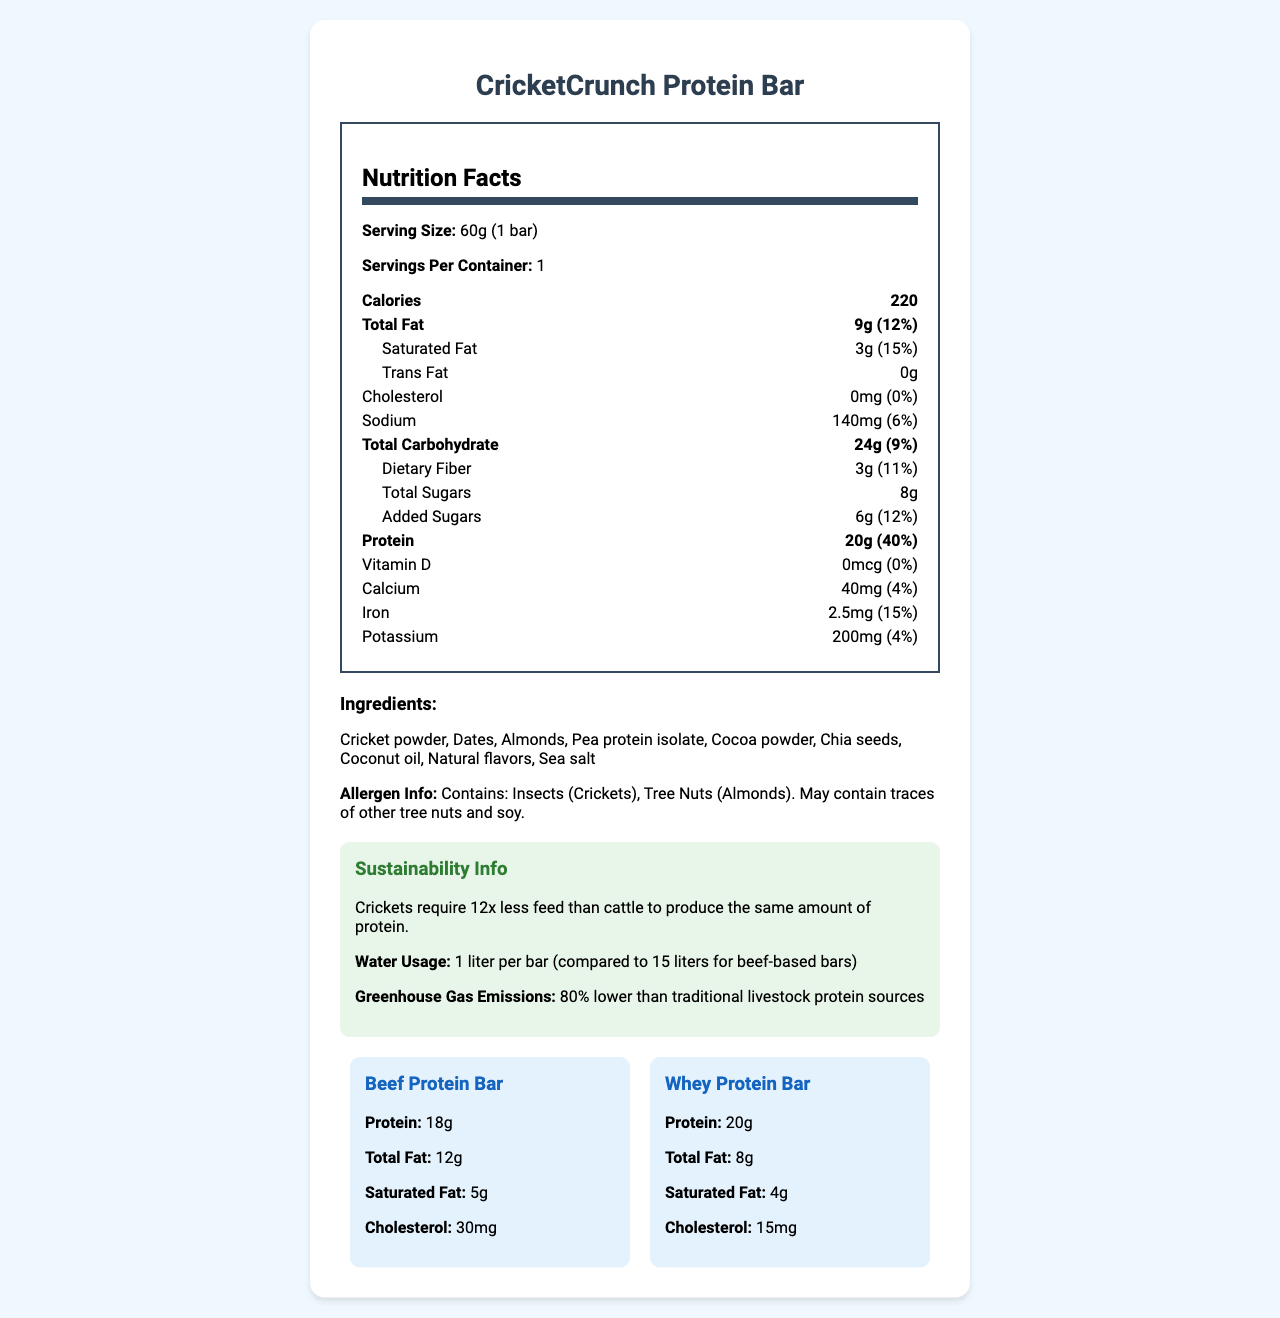what is the serving size of the CricketCrunch Protein Bar? The serving size is clearly listed as "60g (1 bar)" in the document.
Answer: 60g (1 bar) how many calories are there per serving? The document lists the calories per serving as 220.
Answer: 220 how much protein is in the CricketCrunch Protein Bar compared to a traditional beef protein bar? The CricketCrunch Protein Bar contains 20g of protein, while the beef protein bar contains 18g, as stated in the comparison section.
Answer: CricketCrunch Protein Bar: 20g; Beef Protein Bar: 18g what is the percent daily value of iron in the CricketCrunch Protein Bar? The percent daily value of iron is shown as 15% in the nutrition label.
Answer: 15% what are the main ingredients of the CricketCrunch Protein Bar? These ingredients are listed in the ingredients section of the document.
Answer: Cricket powder, Dates, Almonds, Pea protein isolate, Cocoa powder, Chia seeds, Coconut oil, Natural flavors, Sea salt which protein bar has no cholesterol? A. CricketCrunch Protein Bar B. Beef Protein Bar C. Whey Protein Bar The CricketCrunch Protein Bar has 0mg of cholesterol, whereas both the beef and whey protein bars contain cholesterol.
Answer: A. CricketCrunch Protein Bar how much total fat is in the whey protein bar? The total fat content for the whey protein bar is shown as 8g in the comparison section.
Answer: 8g which bar has the highest amount of saturated fat? A. CricketCrunch Protein Bar B. Beef Protein Bar C. Whey Protein Bar The beef protein bar has 5g of saturated fat, which is higher compared to the 4g in the whey protein bar and 3g in the CricketCrunch Protein Bar.
Answer: B. Beef Protein Bar does the CricketCrunch Protein Bar contain any added sugars? The CricketCrunch Protein Bar contains added sugars, as evidenced by the 6g of added sugars listed on the nutrition label.
Answer: Yes are there any allergenic ingredients in the CricketCrunch Protein Bar? The document mentions that the protein bar contains insects (crickets) and tree nuts (almonds) as allergens.
Answer: Yes describe the environmental sustainability aspects highlighted for the CricketCrunch Protein Bar. The sustainability section outlines the efficiency, lower resource usage, and minimized environmental impact associated with cricket protein production.
Answer: The CricketCrunch Protein Bar boasts notable sustainability features: crickets require 12x less feed than cattle to produce the same amount of protein, the water usage is only 1 liter per bar compared to 15 liters for beef-based bars, and the greenhouse gas emissions are 80% lower than traditional livestock protein sources. Additionally, crickets have a higher bioconversion efficiency of up to 80% compared to about 40% for cattle. what is the source of protein in the CricketCrunch Protein Bar? The primary protein source is cricket powder, listed as the first ingredient.
Answer: Crickets (Cricket powder) which bar has the lowest amount of total fat? A. CricketCrunch Protein Bar B. Beef Protein Bar C. Whey Protein Bar The whey protein bar has 8g of total fat, which is the lowest among the options given. The CricketCrunch Protein Bar has 9g and the beef protein bar has 12g.
Answer: C. Whey Protein Bar how much potassium is in the CricketCrunch Protein Bar? The nutrition label lists the potassium content as 200mg.
Answer: 200mg how does the bioconversion efficiency of crickets compare to that of cattle? The document shows that crickets convert up to 80% of their feed into edible weight, whereas cattle convert about 40%.
Answer: Crickets: High (up to 80% of feed converted to edible weight); Cattle: Low (about 40% of feed converted to edible weight) what is the main idea of the document? The document provides a comprehensive overview of the nutritional content, ingredients, allergen information, and sustainability aspects of the CricketCrunch Protein Bar. It also includes a comparison to traditional protein sources and outlines the environmental benefits of using cricket protein.
Answer: The document is a detailed nutrition and sustainability comparison of the CricketCrunch Protein Bar to traditional protein sources like beef and whey. It highlights the high protein content, low environmental impact, and innovative use of crickets as a sustainable protein source. how much energy is expended in producing one CricketCrunch Protein Bar? The document does not provide any details regarding the energy expenditure involved in producing one protein bar.
Answer: Not enough information 